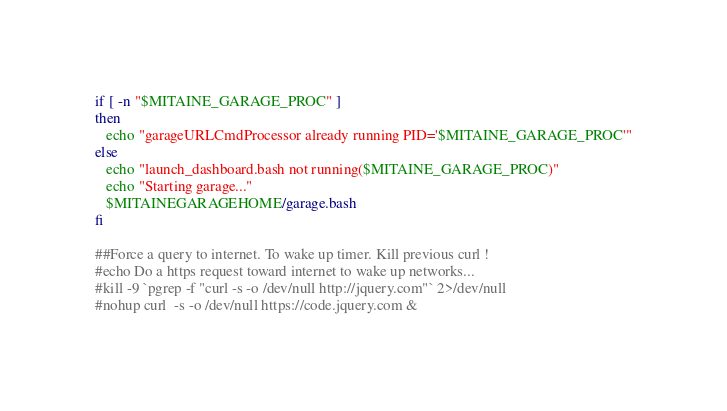<code> <loc_0><loc_0><loc_500><loc_500><_Bash_>if [ -n "$MITAINE_GARAGE_PROC" ]
then
   echo "garageURLCmdProcessor already running PID='$MITAINE_GARAGE_PROC'"
else
   echo "launch_dashboard.bash not running($MITAINE_GARAGE_PROC)"
   echo "Starting garage..."
   $MITAINEGARAGEHOME/garage.bash
fi

##Force a query to internet. To wake up timer. Kill previous curl !
#echo Do a https request toward internet to wake up networks...
#kill -9 `pgrep -f "curl -s -o /dev/null http://jquery.com"` 2>/dev/null
#nohup curl  -s -o /dev/null https://code.jquery.com &

</code> 